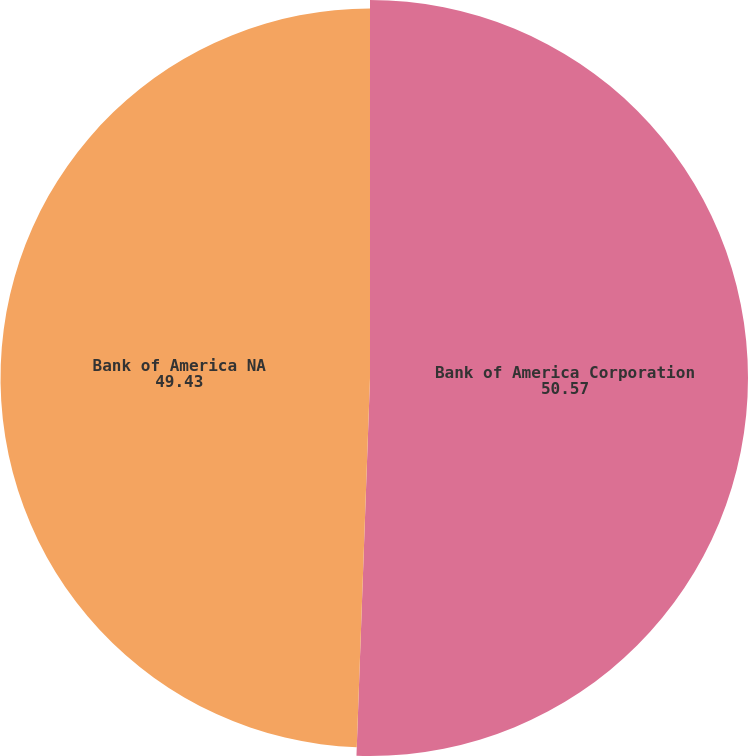Convert chart. <chart><loc_0><loc_0><loc_500><loc_500><pie_chart><fcel>Bank of America Corporation<fcel>Bank of America NA<nl><fcel>50.57%<fcel>49.43%<nl></chart> 